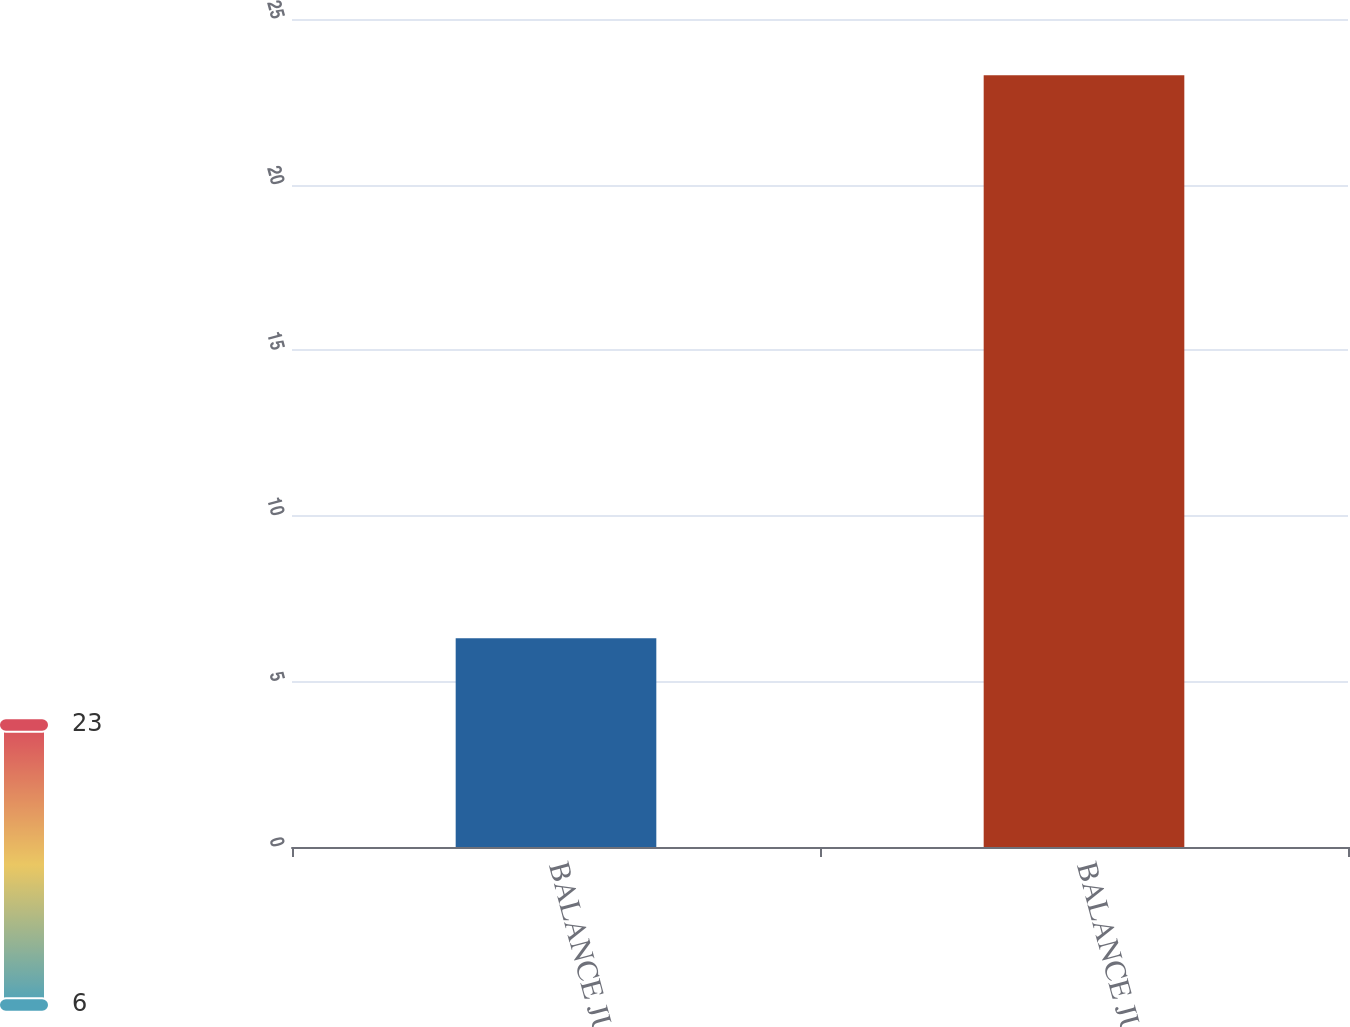Convert chart. <chart><loc_0><loc_0><loc_500><loc_500><bar_chart><fcel>BALANCE JUNE 30 2004<fcel>BALANCE JUNE 30 2005<nl><fcel>6.3<fcel>23.3<nl></chart> 